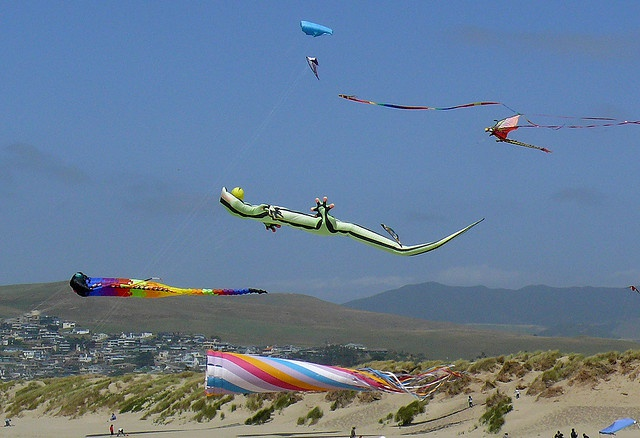Describe the objects in this image and their specific colors. I can see kite in gray, darkgray, lavender, and maroon tones, kite in gray, black, olive, and beige tones, kite in gray, black, olive, and navy tones, kite in gray, black, and maroon tones, and kite in gray, blue, lightblue, and darkblue tones in this image. 